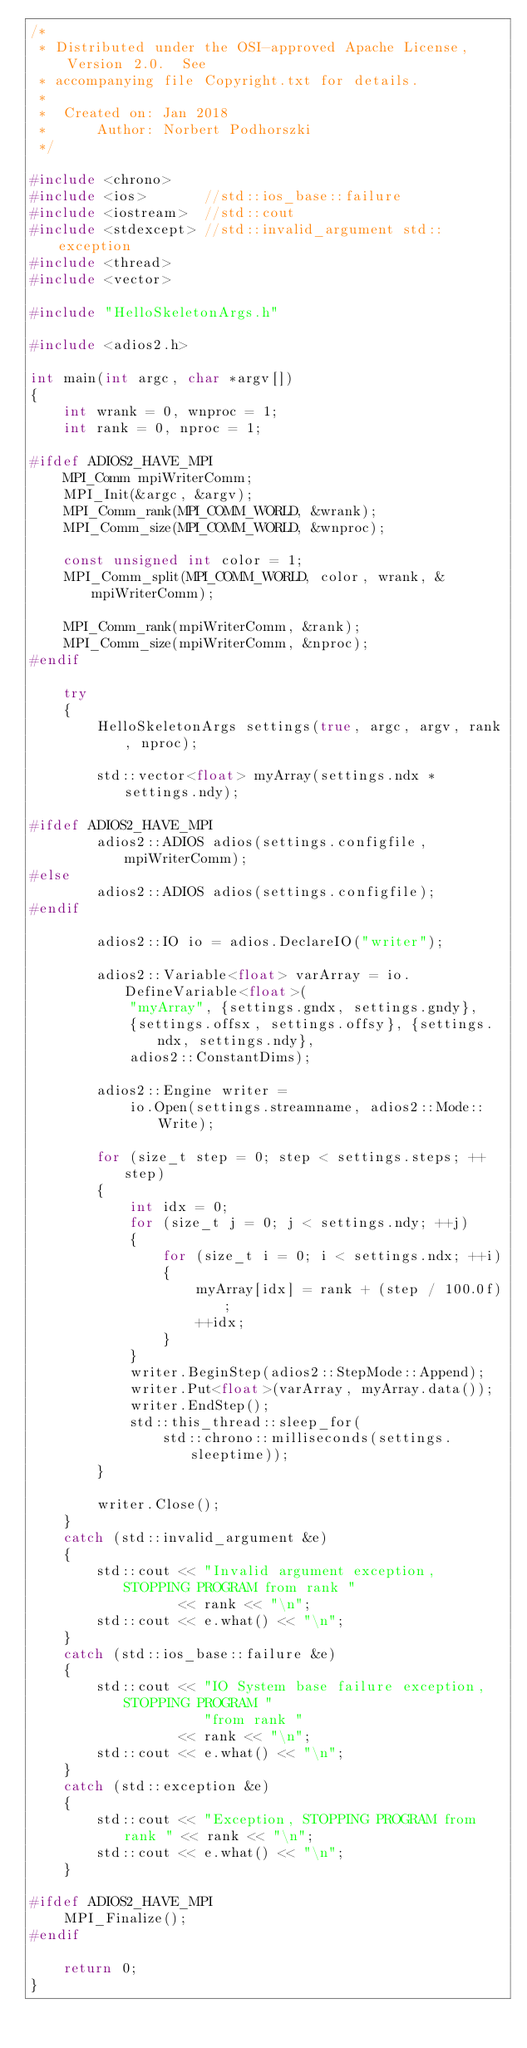<code> <loc_0><loc_0><loc_500><loc_500><_C++_>/*
 * Distributed under the OSI-approved Apache License, Version 2.0.  See
 * accompanying file Copyright.txt for details.
 *
 *  Created on: Jan 2018
 *      Author: Norbert Podhorszki
 */

#include <chrono>
#include <ios>       //std::ios_base::failure
#include <iostream>  //std::cout
#include <stdexcept> //std::invalid_argument std::exception
#include <thread>
#include <vector>

#include "HelloSkeletonArgs.h"

#include <adios2.h>

int main(int argc, char *argv[])
{
    int wrank = 0, wnproc = 1;
    int rank = 0, nproc = 1;

#ifdef ADIOS2_HAVE_MPI
    MPI_Comm mpiWriterComm;
    MPI_Init(&argc, &argv);
    MPI_Comm_rank(MPI_COMM_WORLD, &wrank);
    MPI_Comm_size(MPI_COMM_WORLD, &wnproc);

    const unsigned int color = 1;
    MPI_Comm_split(MPI_COMM_WORLD, color, wrank, &mpiWriterComm);

    MPI_Comm_rank(mpiWriterComm, &rank);
    MPI_Comm_size(mpiWriterComm, &nproc);
#endif

    try
    {
        HelloSkeletonArgs settings(true, argc, argv, rank, nproc);

        std::vector<float> myArray(settings.ndx * settings.ndy);

#ifdef ADIOS2_HAVE_MPI
        adios2::ADIOS adios(settings.configfile, mpiWriterComm);
#else
        adios2::ADIOS adios(settings.configfile);
#endif

        adios2::IO io = adios.DeclareIO("writer");

        adios2::Variable<float> varArray = io.DefineVariable<float>(
            "myArray", {settings.gndx, settings.gndy},
            {settings.offsx, settings.offsy}, {settings.ndx, settings.ndy},
            adios2::ConstantDims);

        adios2::Engine writer =
            io.Open(settings.streamname, adios2::Mode::Write);

        for (size_t step = 0; step < settings.steps; ++step)
        {
            int idx = 0;
            for (size_t j = 0; j < settings.ndy; ++j)
            {
                for (size_t i = 0; i < settings.ndx; ++i)
                {
                    myArray[idx] = rank + (step / 100.0f);
                    ++idx;
                }
            }
            writer.BeginStep(adios2::StepMode::Append);
            writer.Put<float>(varArray, myArray.data());
            writer.EndStep();
            std::this_thread::sleep_for(
                std::chrono::milliseconds(settings.sleeptime));
        }

        writer.Close();
    }
    catch (std::invalid_argument &e)
    {
        std::cout << "Invalid argument exception, STOPPING PROGRAM from rank "
                  << rank << "\n";
        std::cout << e.what() << "\n";
    }
    catch (std::ios_base::failure &e)
    {
        std::cout << "IO System base failure exception, STOPPING PROGRAM "
                     "from rank "
                  << rank << "\n";
        std::cout << e.what() << "\n";
    }
    catch (std::exception &e)
    {
        std::cout << "Exception, STOPPING PROGRAM from rank " << rank << "\n";
        std::cout << e.what() << "\n";
    }

#ifdef ADIOS2_HAVE_MPI
    MPI_Finalize();
#endif

    return 0;
}
</code> 